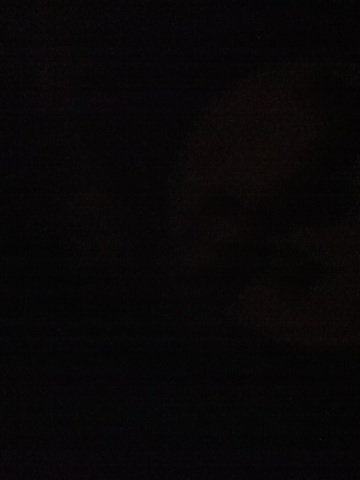What kind city this is? The image is too dark to determine the type of city. 